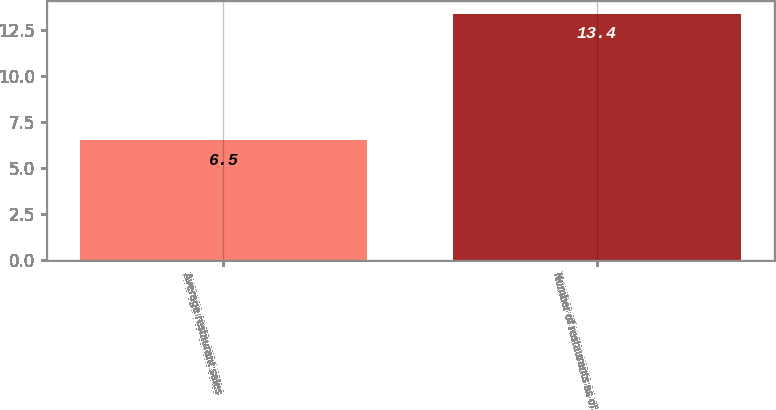Convert chart to OTSL. <chart><loc_0><loc_0><loc_500><loc_500><bar_chart><fcel>Average restaurant sales<fcel>Number of restaurants as of<nl><fcel>6.5<fcel>13.4<nl></chart> 